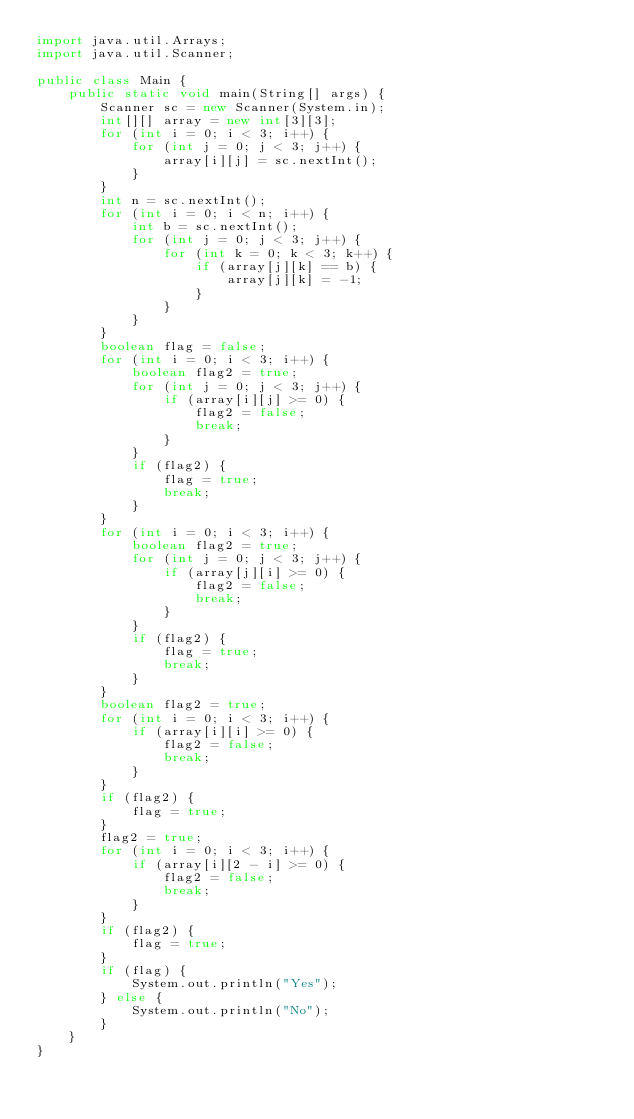Convert code to text. <code><loc_0><loc_0><loc_500><loc_500><_Java_>import java.util.Arrays;
import java.util.Scanner;

public class Main {
	public static void main(String[] args) {
		Scanner sc = new Scanner(System.in);
		int[][] array = new int[3][3];
		for (int i = 0; i < 3; i++) {
			for (int j = 0; j < 3; j++) {
				array[i][j] = sc.nextInt();
			}
		}
		int n = sc.nextInt();
		for (int i = 0; i < n; i++) {
			int b = sc.nextInt();
			for (int j = 0; j < 3; j++) {
				for (int k = 0; k < 3; k++) {
					if (array[j][k] == b) {
						array[j][k] = -1;
					}
				}
			}
		}
		boolean flag = false;
		for (int i = 0; i < 3; i++) {
			boolean flag2 = true;
			for (int j = 0; j < 3; j++) {
				if (array[i][j] >= 0) {
					flag2 = false;
					break;
				}
			}
			if (flag2) {
				flag = true;
				break;
			}
		}
		for (int i = 0; i < 3; i++) {
			boolean flag2 = true;
			for (int j = 0; j < 3; j++) {
				if (array[j][i] >= 0) {
					flag2 = false;
					break;
				}
			}
			if (flag2) {
				flag = true;
				break;
			}
		}
		boolean flag2 = true;
		for (int i = 0; i < 3; i++) {
			if (array[i][i] >= 0) {
				flag2 = false;
				break;
			}
		}
		if (flag2) {
			flag = true;
		}
		flag2 = true;
		for (int i = 0; i < 3; i++) {
			if (array[i][2 - i] >= 0) {
				flag2 = false;
				break;
			}
		}
		if (flag2) {
			flag = true;
		}
		if (flag) {
			System.out.println("Yes");
		} else {
			System.out.println("No");
		}
	}
}
</code> 